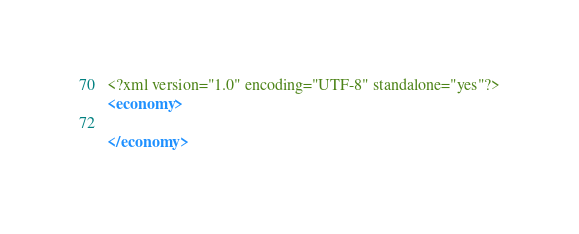<code> <loc_0><loc_0><loc_500><loc_500><_XML_><?xml version="1.0" encoding="UTF-8" standalone="yes"?>
<economy>

</economy>
</code> 